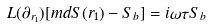Convert formula to latex. <formula><loc_0><loc_0><loc_500><loc_500>L ( \partial _ { r _ { 1 } } ) [ m d { S } ( r _ { 1 } ) - S _ { b } ] = i \omega \tau S _ { b }</formula> 